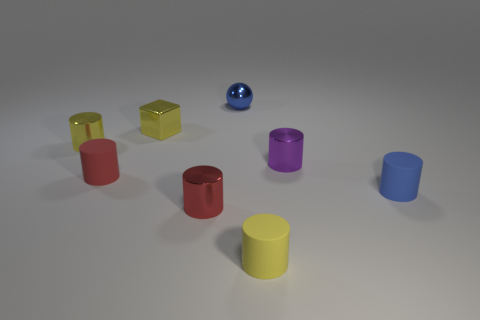What is the shape of the small blue object that is made of the same material as the yellow cube?
Your answer should be very brief. Sphere. What number of metal things are small green objects or yellow cylinders?
Ensure brevity in your answer.  1. There is a tiny blue thing that is right of the metallic object that is behind the yellow cube; how many small blue balls are behind it?
Your response must be concise. 1. Is the size of the metallic cylinder that is in front of the purple metal cylinder the same as the yellow thing that is right of the small sphere?
Offer a terse response. Yes. What material is the small purple object that is the same shape as the yellow rubber thing?
Offer a very short reply. Metal. How many large things are yellow shiny cylinders or yellow shiny cubes?
Offer a terse response. 0. What is the small purple thing made of?
Provide a succinct answer. Metal. What material is the cylinder that is both behind the red matte thing and in front of the yellow metallic cylinder?
Your answer should be very brief. Metal. Does the small shiny cube have the same color as the small ball behind the tiny red rubber thing?
Your answer should be compact. No. There is a yellow cube that is the same size as the blue metallic ball; what is it made of?
Your answer should be compact. Metal. 